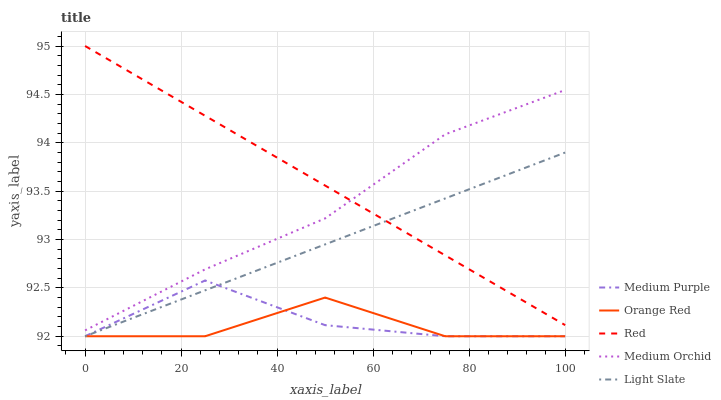Does Orange Red have the minimum area under the curve?
Answer yes or no. Yes. Does Red have the maximum area under the curve?
Answer yes or no. Yes. Does Light Slate have the minimum area under the curve?
Answer yes or no. No. Does Light Slate have the maximum area under the curve?
Answer yes or no. No. Is Red the smoothest?
Answer yes or no. Yes. Is Orange Red the roughest?
Answer yes or no. Yes. Is Light Slate the smoothest?
Answer yes or no. No. Is Light Slate the roughest?
Answer yes or no. No. Does Medium Purple have the lowest value?
Answer yes or no. Yes. Does Medium Orchid have the lowest value?
Answer yes or no. No. Does Red have the highest value?
Answer yes or no. Yes. Does Light Slate have the highest value?
Answer yes or no. No. Is Orange Red less than Medium Orchid?
Answer yes or no. Yes. Is Red greater than Medium Purple?
Answer yes or no. Yes. Does Red intersect Medium Orchid?
Answer yes or no. Yes. Is Red less than Medium Orchid?
Answer yes or no. No. Is Red greater than Medium Orchid?
Answer yes or no. No. Does Orange Red intersect Medium Orchid?
Answer yes or no. No. 